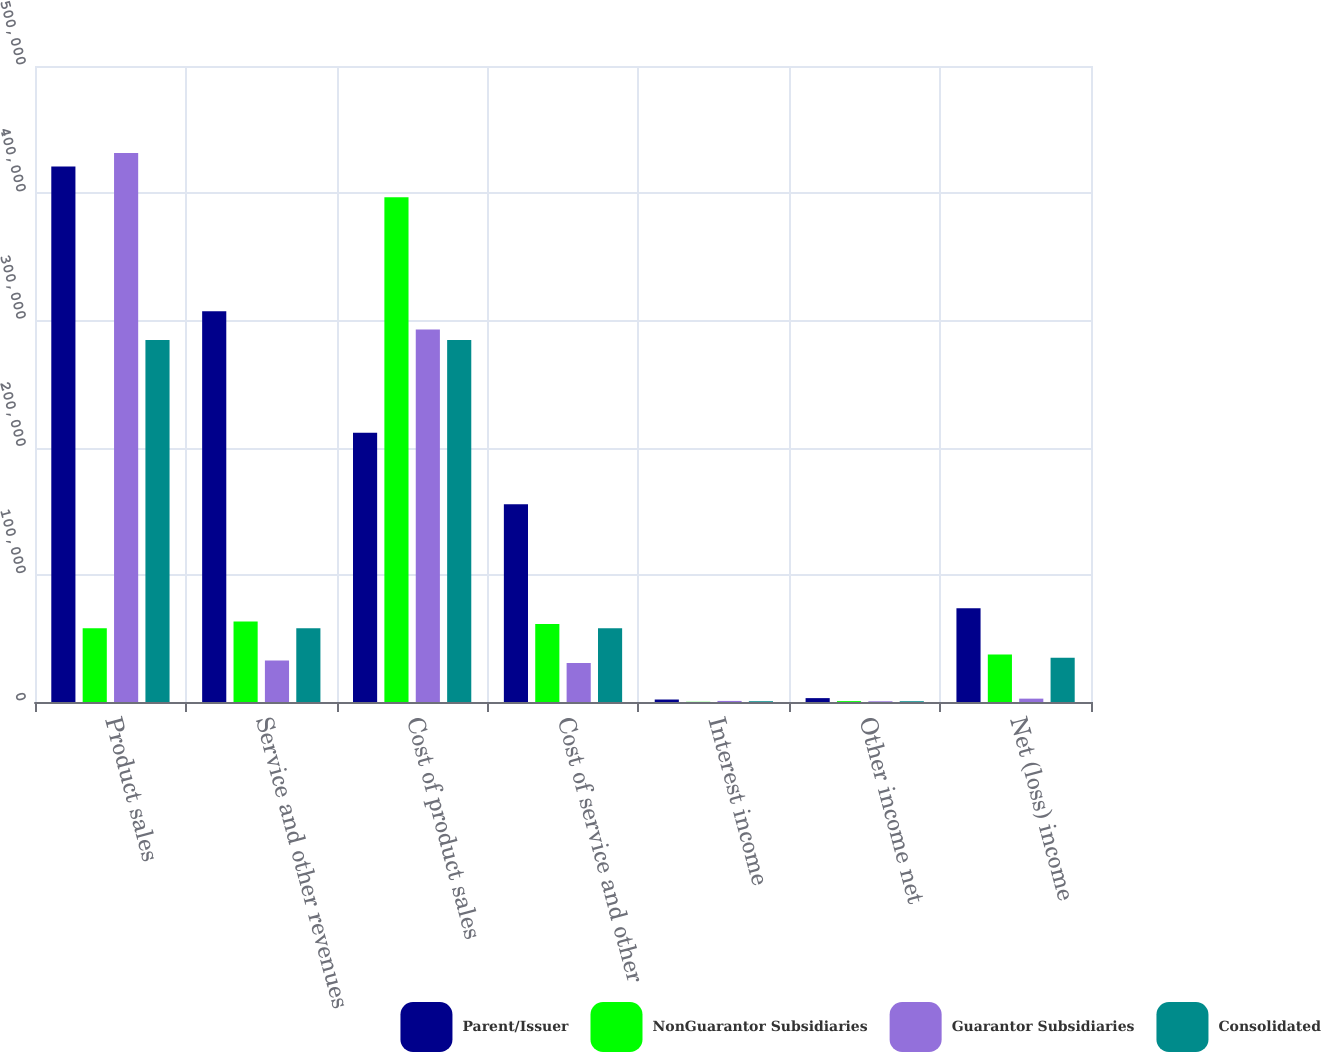Convert chart. <chart><loc_0><loc_0><loc_500><loc_500><stacked_bar_chart><ecel><fcel>Product sales<fcel>Service and other revenues<fcel>Cost of product sales<fcel>Cost of service and other<fcel>Interest income<fcel>Other income net<fcel>Net (loss) income<nl><fcel>Parent/Issuer<fcel>420960<fcel>307097<fcel>211665<fcel>155555<fcel>1950<fcel>3051<fcel>73634<nl><fcel>NonGuarantor Subsidiaries<fcel>58041<fcel>63313<fcel>396747<fcel>61285<fcel>159<fcel>699<fcel>37385<nl><fcel>Guarantor Subsidiaries<fcel>431689<fcel>32555<fcel>292928<fcel>30713<fcel>840<fcel>557<fcel>2640<nl><fcel>Consolidated<fcel>284501<fcel>58041<fcel>284501<fcel>58041<fcel>609<fcel>609<fcel>34745<nl></chart> 